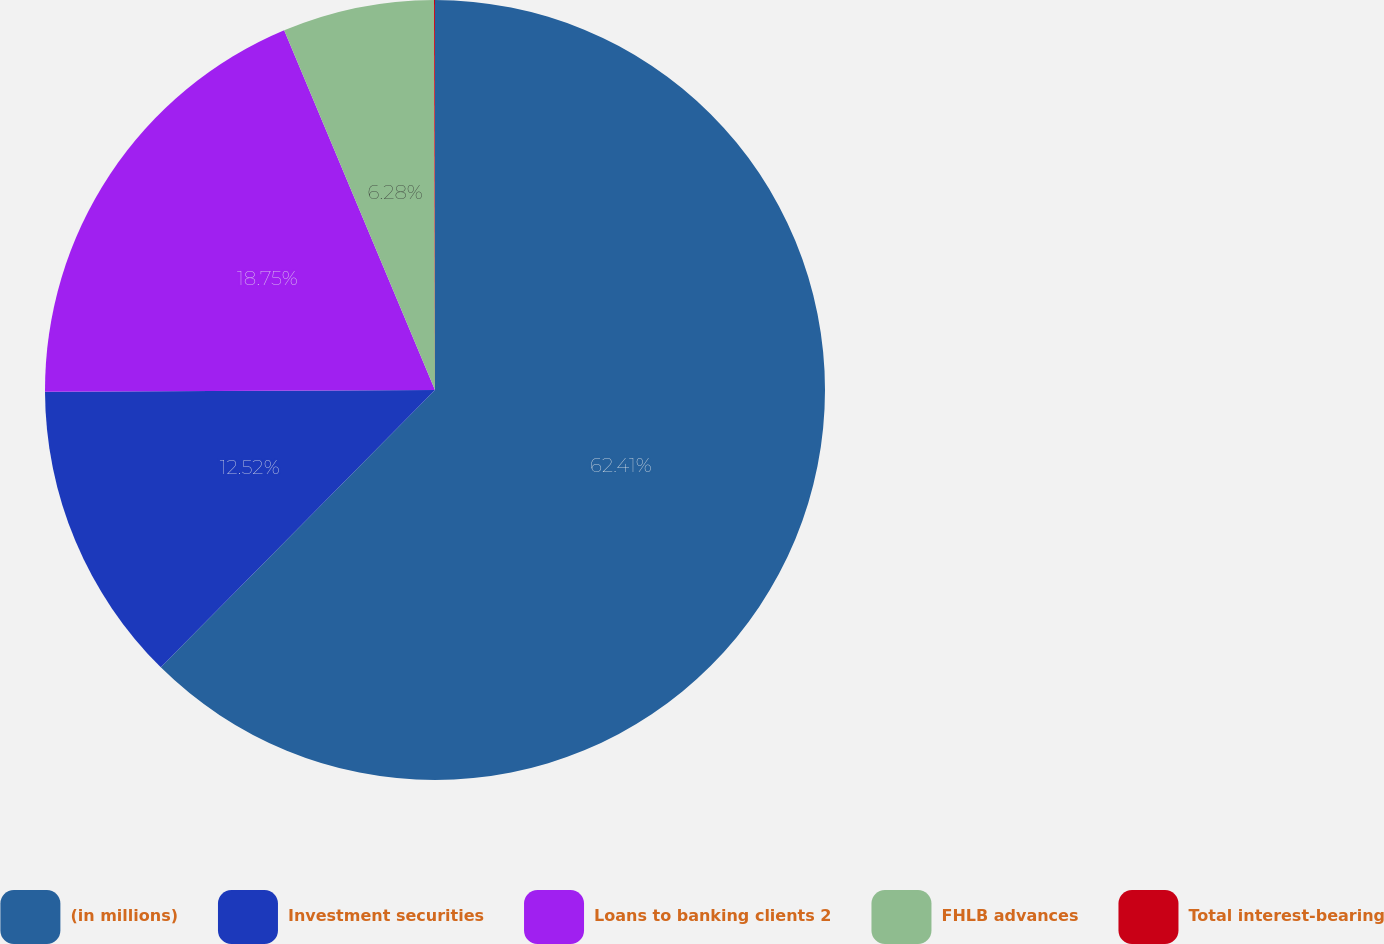Convert chart. <chart><loc_0><loc_0><loc_500><loc_500><pie_chart><fcel>(in millions)<fcel>Investment securities<fcel>Loans to banking clients 2<fcel>FHLB advances<fcel>Total interest-bearing<nl><fcel>62.41%<fcel>12.52%<fcel>18.75%<fcel>6.28%<fcel>0.04%<nl></chart> 